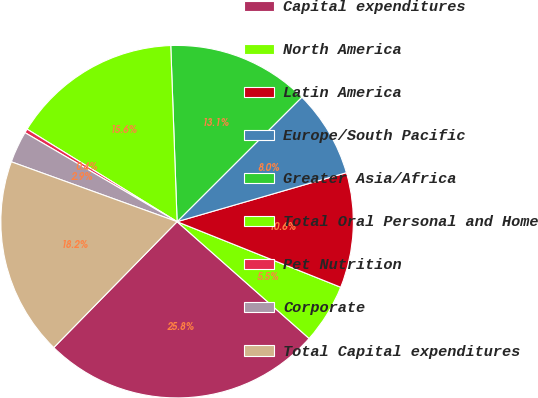Convert chart. <chart><loc_0><loc_0><loc_500><loc_500><pie_chart><fcel>Capital expenditures<fcel>North America<fcel>Latin America<fcel>Europe/South Pacific<fcel>Greater Asia/Africa<fcel>Total Oral Personal and Home<fcel>Pet Nutrition<fcel>Corporate<fcel>Total Capital expenditures<nl><fcel>25.81%<fcel>5.46%<fcel>10.55%<fcel>8.0%<fcel>13.09%<fcel>15.63%<fcel>0.37%<fcel>2.91%<fcel>18.18%<nl></chart> 